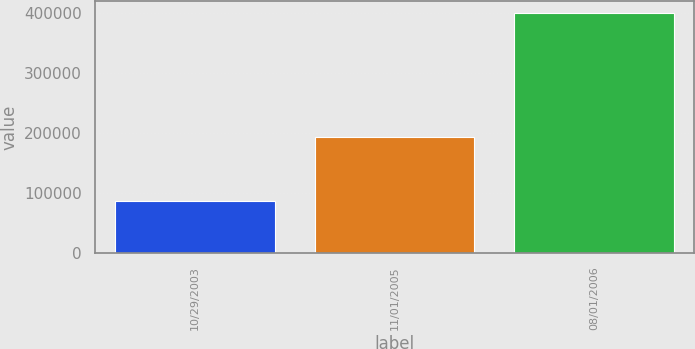<chart> <loc_0><loc_0><loc_500><loc_500><bar_chart><fcel>10/29/2003<fcel>11/01/2005<fcel>08/01/2006<nl><fcel>86340<fcel>192650<fcel>400813<nl></chart> 